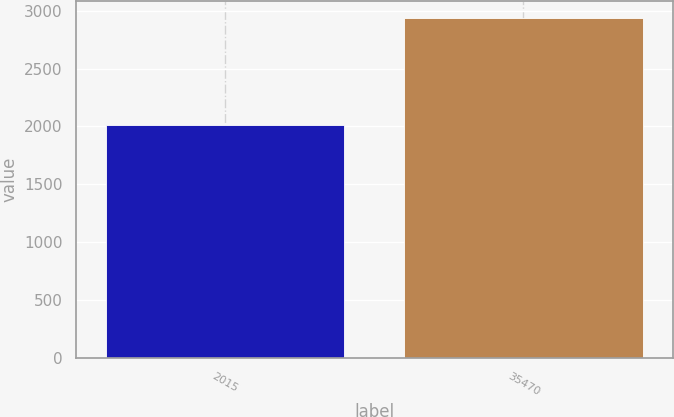Convert chart to OTSL. <chart><loc_0><loc_0><loc_500><loc_500><bar_chart><fcel>2015<fcel>35470<nl><fcel>2014<fcel>2934.8<nl></chart> 